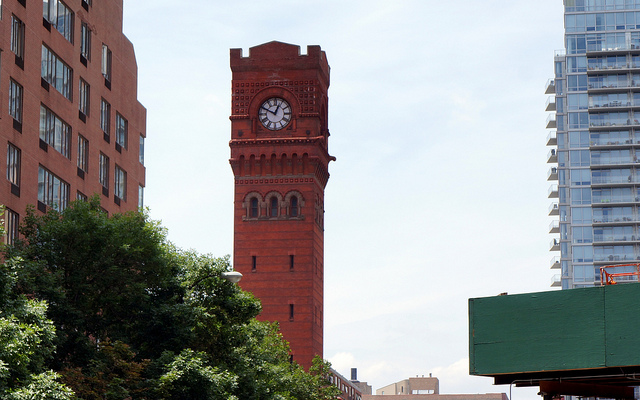What might be the historical significance of this clock tower? The clock tower could hold historical significance as a prominent landmark from a specific period, possibly serving as a symbol of continuity and the passing of time in a changing urban landscape. 